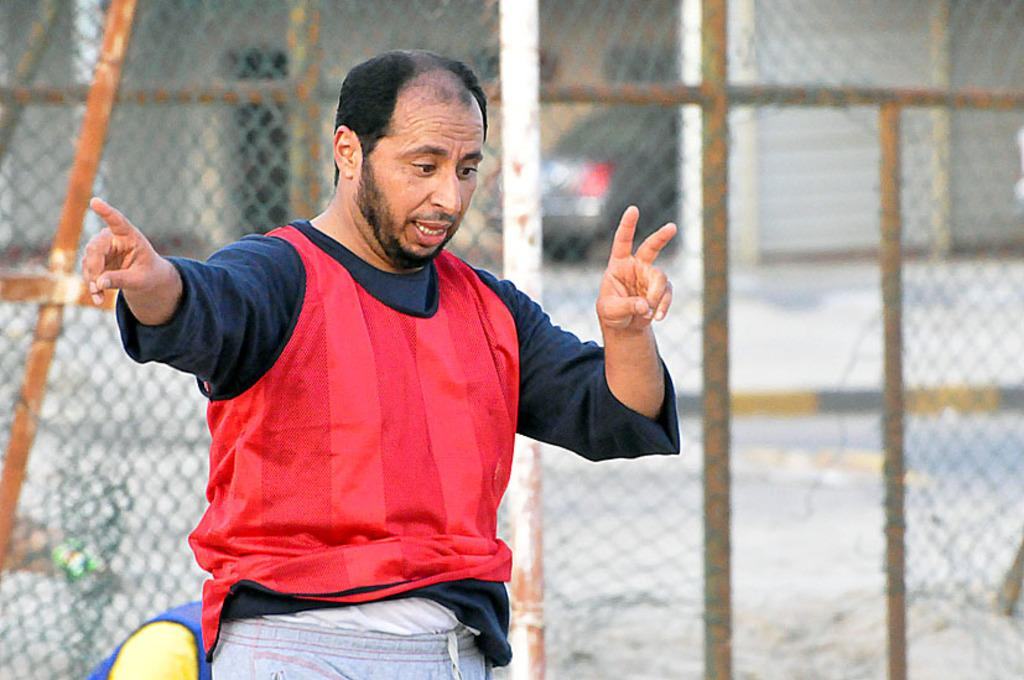Who or what is in the front of the image? There is a person in the front of the image. What can be observed about the background of the image? The background of the image is blurry. What type of material is present in the image? There is a mesh in the image. What else can be seen in the image besides the person and the mesh? There are objects in the image. What type of steel treatment is being applied to the person in the image? There is no steel or steel treatment present in the image; it features a person and other elements. 